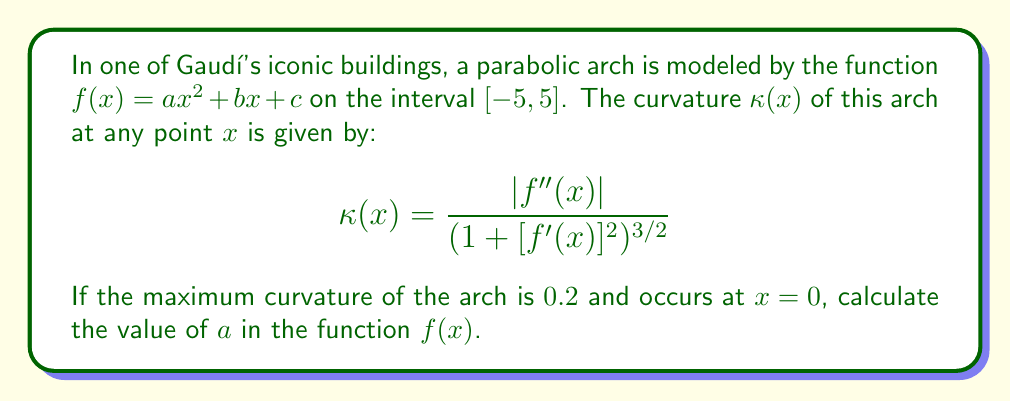Provide a solution to this math problem. Let's approach this step-by-step:

1) First, we need to find $f'(x)$ and $f''(x)$:
   $f'(x) = 2ax + b$
   $f''(x) = 2a$

2) The curvature formula becomes:
   $$\kappa(x) = \frac{|2a|}{(1 + [2ax + b]^2)^{3/2}}$$

3) We're told that the maximum curvature occurs at $x = 0$. At this point:
   $$\kappa(0) = \frac{|2a|}{(1 + b^2)^{3/2}} = 0.2$$

4) The maximum curvature occurring at $x = 0$ implies that $f'(0) = 0$, which means $b = 0$.

5) Our equation simplifies to:
   $$\frac{|2a|}{1^{3/2}} = 0.2$$

6) Solving for $a$:
   $|2a| = 0.2$
   $2a = 0.2$ (since $a$ is positive for a concave-up parabola)
   $a = 0.1$

Thus, the value of $a$ in the function $f(x) = ax^2 + bx + c$ is 0.1.
Answer: $a = 0.1$ 